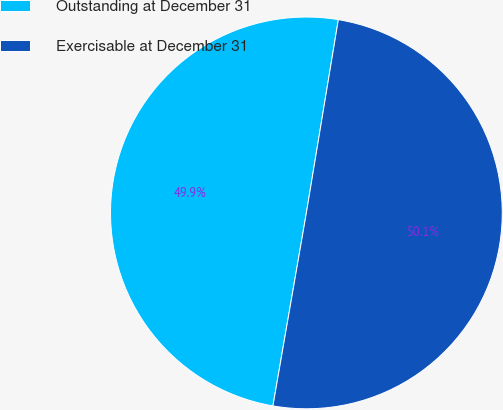<chart> <loc_0><loc_0><loc_500><loc_500><pie_chart><fcel>Outstanding at December 31<fcel>Exercisable at December 31<nl><fcel>49.88%<fcel>50.12%<nl></chart> 